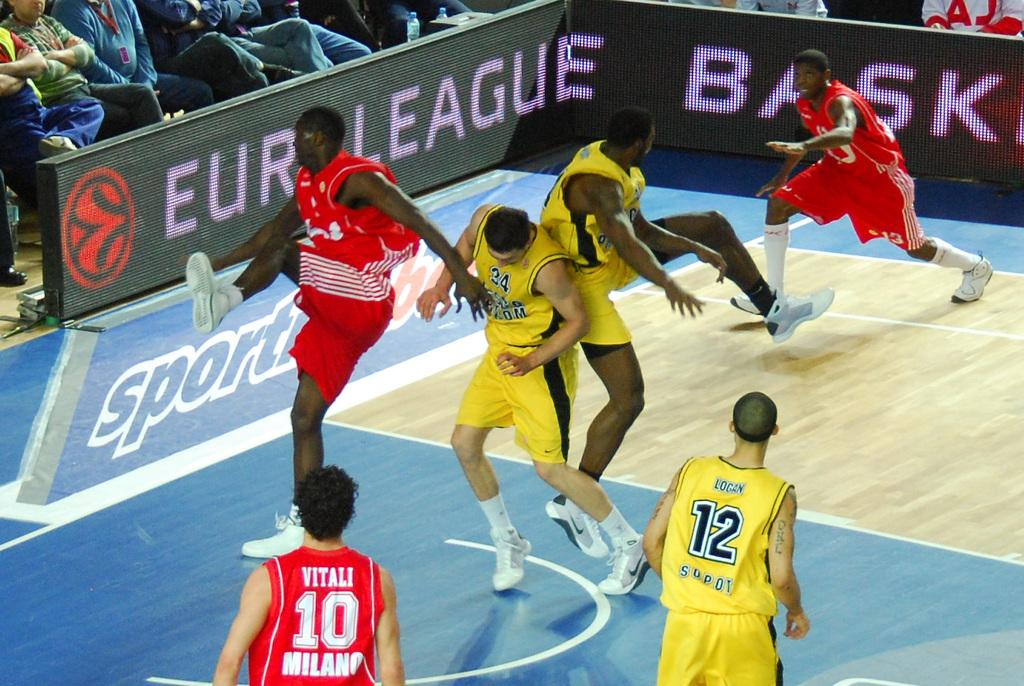<image>
Give a short and clear explanation of the subsequent image. a group of basketball players with one wearing the number 10 on it 